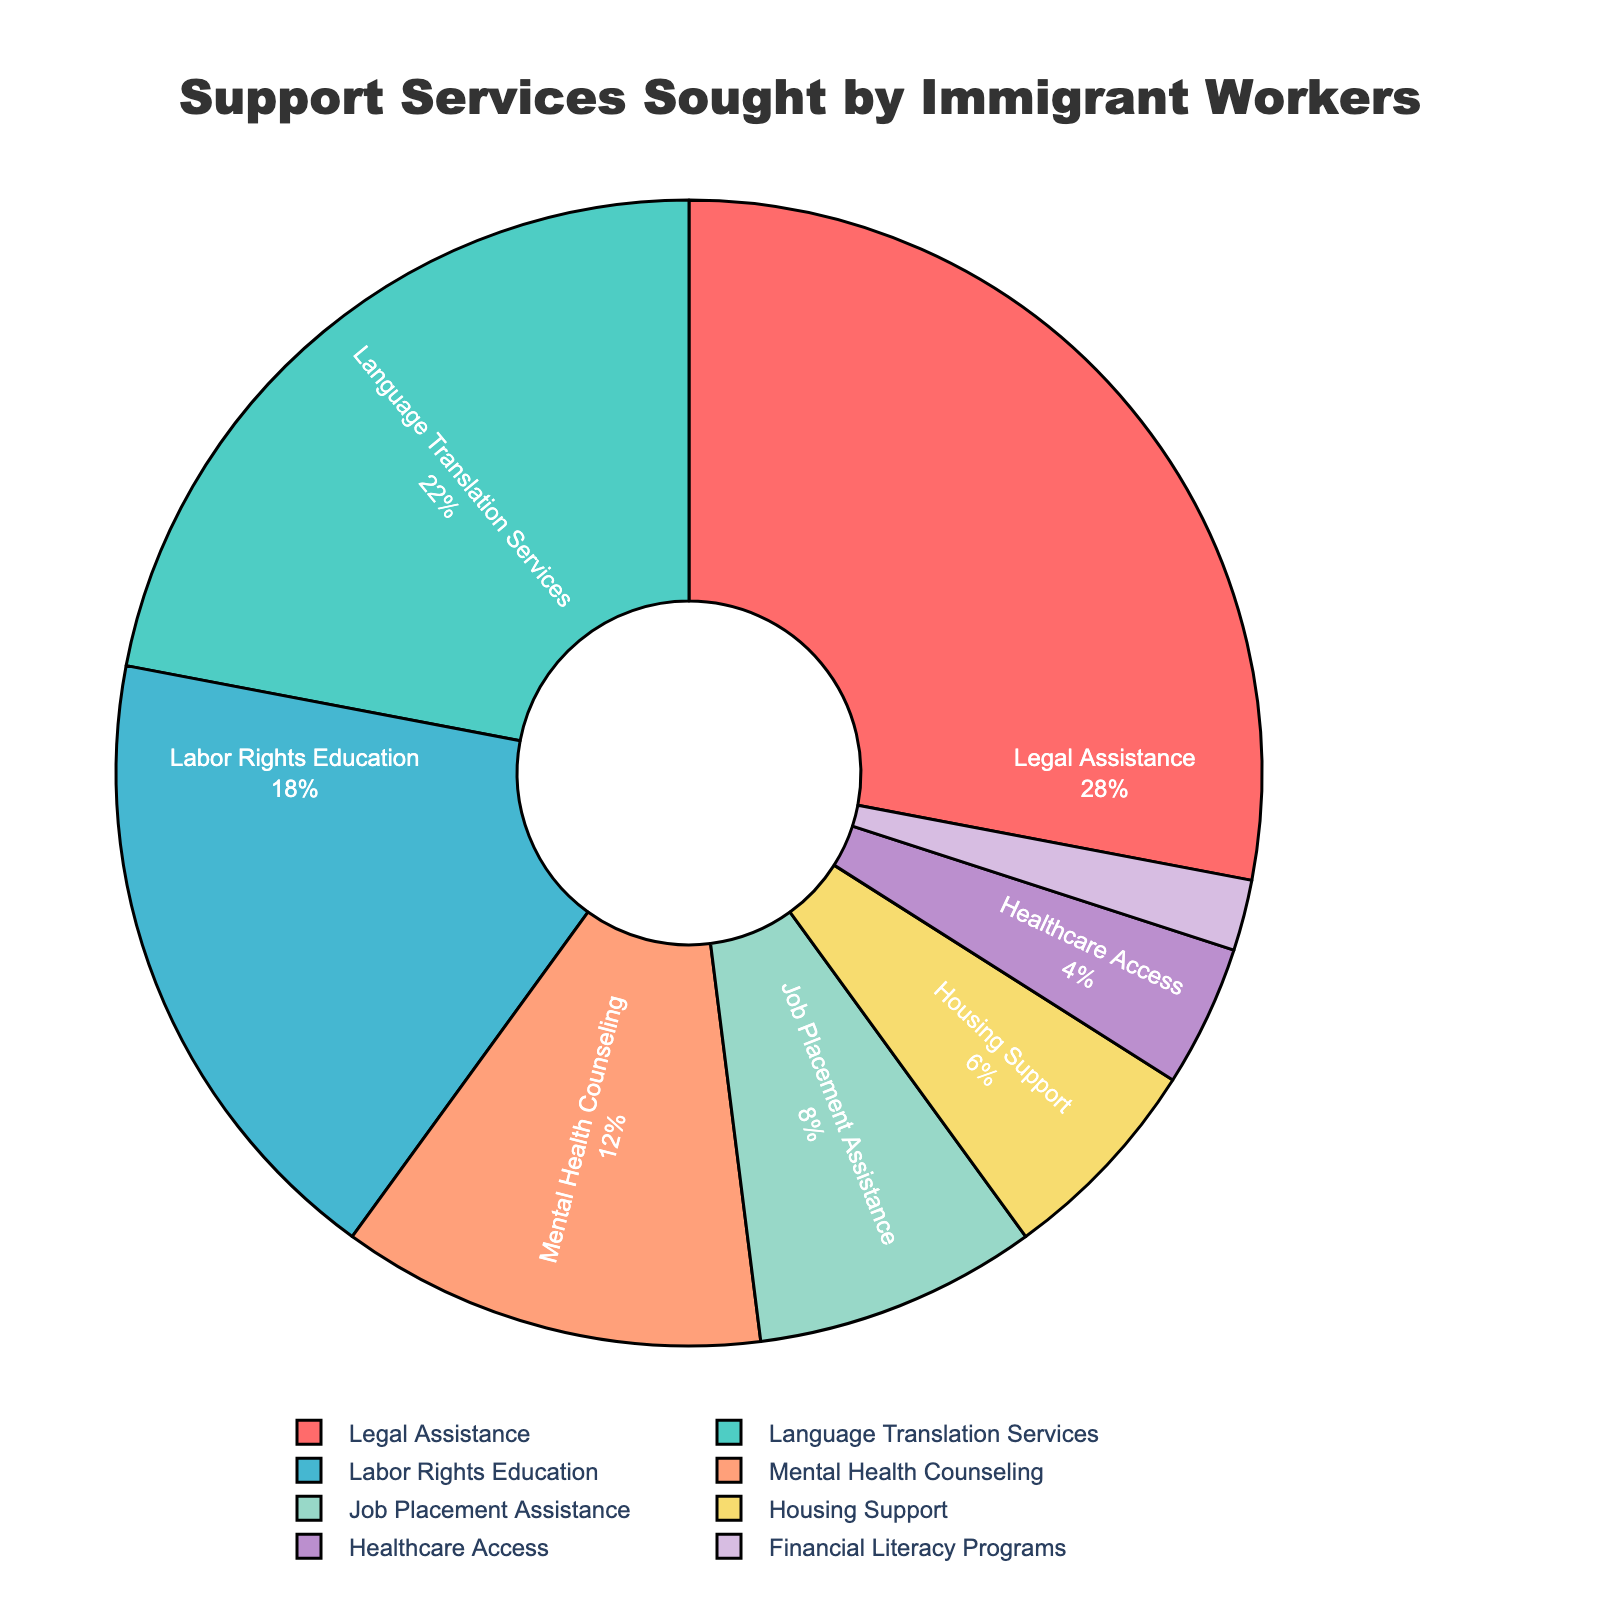What percentage of immigrant workers sought labor rights education support? According to the pie chart, the segment labeled "Labor Rights Education" represents 18% of the total.
Answer: 18% Which type of support was sought the least by immigrant workers? By comparing the segments of the pie chart, the smallest segment corresponds to "Financial Literacy Programs", representing 2%.
Answer: Financial Literacy Programs How much more popular is legal assistance compared to healthcare access? Legal assistance represents 28% while healthcare access is 4%. The difference is 28% - 4% = 24%.
Answer: 24% What is the combined percentage of immigrant workers seeking mental health counseling and job placement assistance? Mental health counseling is 12% and job placement assistance is 8%. Their sum is 12% + 8% = 20%.
Answer: 20% How does the percentage of those seeking language translation services compare to those seeking housing support? Language translation services represent 22% while housing support is 6%. Language translation services are 22% - 6% = 16% more common.
Answer: 16% What percentage of support services sought involve basic life needs such as housing and healthcare access? Housing support is 6% and healthcare access is 4%. Their total is 6% + 4% = 10%.
Answer: 10% Identify the type of support service in a green segment of the pie chart. The green segment of the pie chart corresponds to "Language Translation Services".
Answer: Language Translation Services What is the percentage difference between the most popular and least popular support services? The most popular is legal assistance at 28% and the least popular is financial literacy programs at 2%. The difference is 28% - 2% = 26%.
Answer: 26% Between labor rights education and mental health counseling, which has a higher percentage and by how much? Labor rights education is at 18% while mental health counseling is at 12%. The difference is 18% - 12% = 6%.
Answer: Labor Rights Education, 6% If you sum up the percentages for legal assistance, language translation services, and labor rights education, what do you get? Legal assistance is 28%, language translation services is 22%, and labor rights education is 18%. Their sum is 28% + 22% + 18% = 68%.
Answer: 68% 